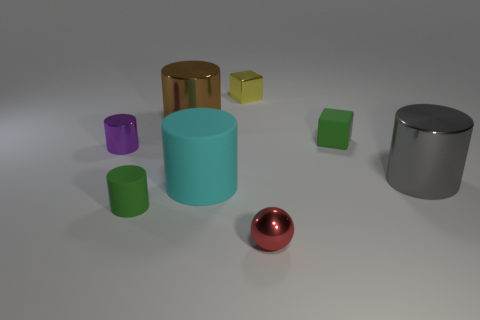Subtract all green cylinders. How many cylinders are left? 4 Subtract all gray cylinders. How many cylinders are left? 4 Add 1 large green rubber balls. How many objects exist? 9 Subtract all red cylinders. Subtract all gray balls. How many cylinders are left? 5 Subtract all cylinders. How many objects are left? 3 Add 4 big gray things. How many big gray things exist? 5 Subtract 0 blue cylinders. How many objects are left? 8 Subtract all big rubber things. Subtract all tiny purple shiny things. How many objects are left? 6 Add 2 cyan things. How many cyan things are left? 3 